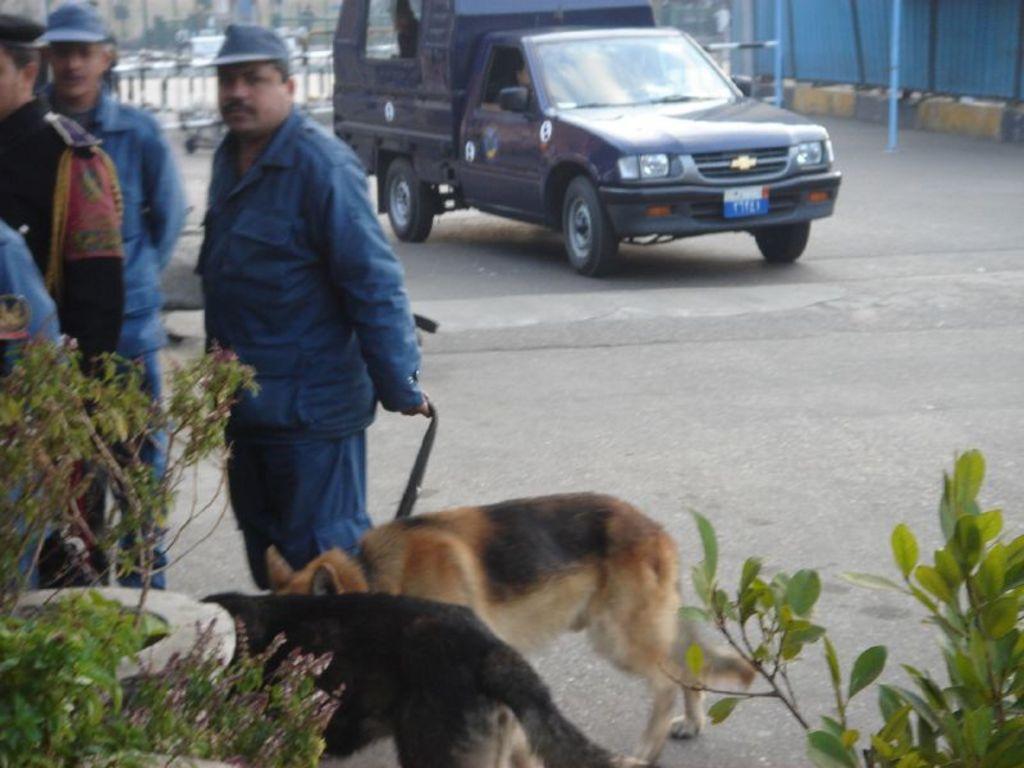Can you describe this image briefly? In this image there are two dog and four men, in the bottom left there are plants and in the bottom right there is a plant, in the background there is a van on the road. 